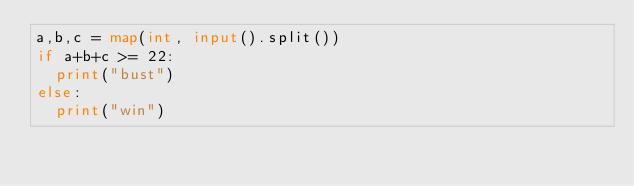<code> <loc_0><loc_0><loc_500><loc_500><_Python_>a,b,c = map(int, input().split())
if a+b+c >= 22:
  print("bust")
else:
  print("win")</code> 